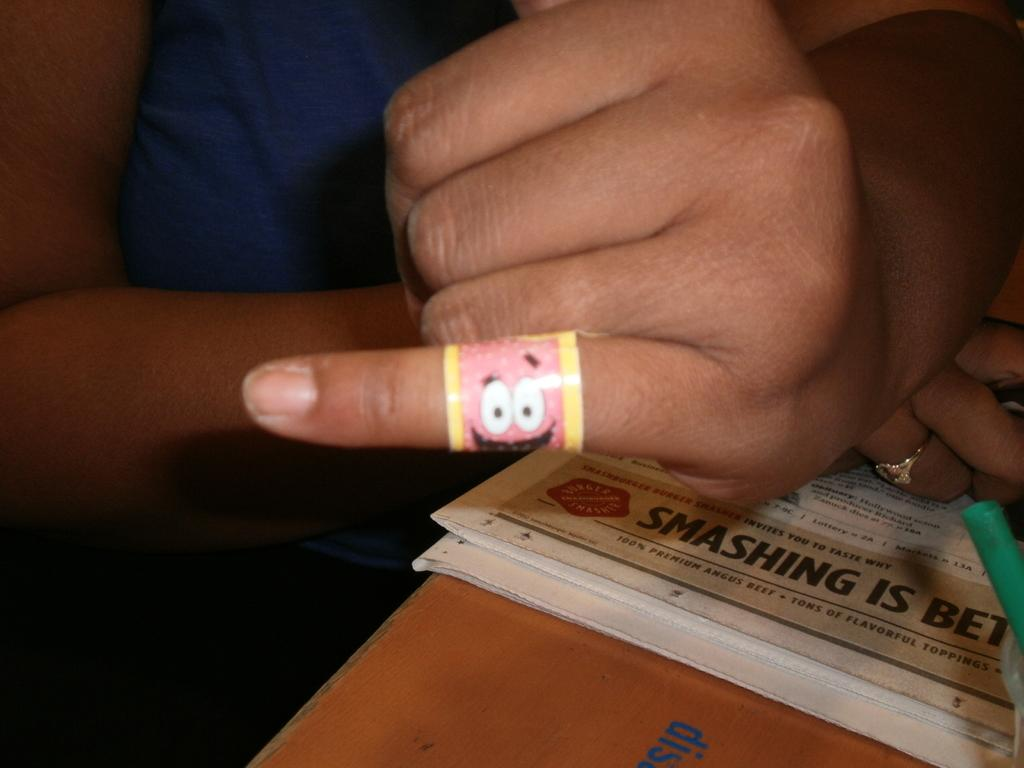What body parts are visible in the image? There are a woman's hands and fingers in the image. What object is located at the bottom of the image? There is a newspaper on the bottom side of the image. Can you describe the background of the image? The background of the image is blurred. How many boys are playing with the drawer in the image? There are no boys or drawers present in the image. Is there any water visible in the image? There is no water visible in the image. 